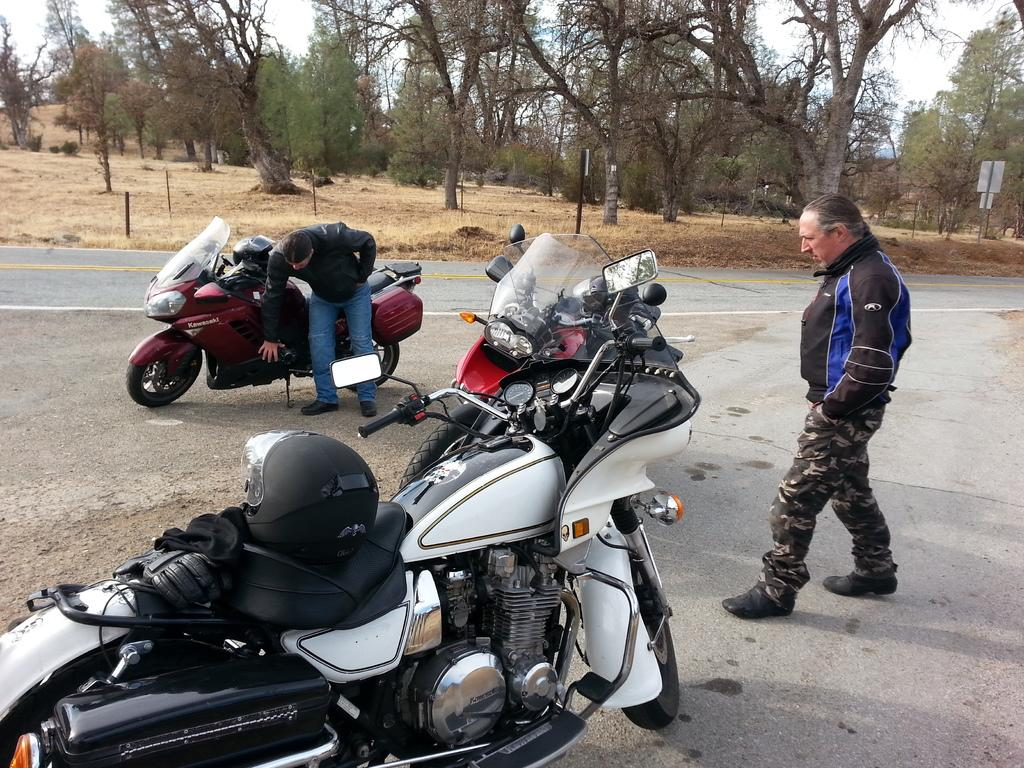How many bikes are in the image? There are three bikes in the image. How many people are in the image? There are two persons in the image. What is at the bottom of the image? There is a road at the bottom of the image. What can be seen in the background of the image? There are many trees and dry grass in the background of the image. How many socks are visible on the feet of the persons in the image? There is no information about socks or feet in the image, so we cannot determine the number of socks visible. 